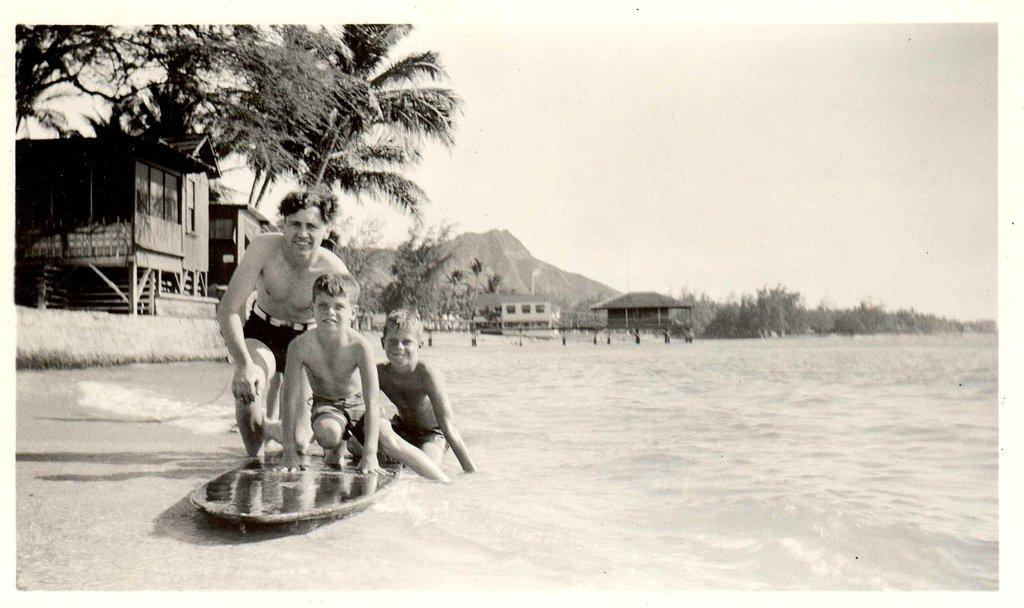What are the people in the image standing on? The people are on an object in the image. What can be seen below the object in the image? The ground is visible in the image. What type of structures can be seen in the image? There are water huts in the image. What type of natural features are present in the image? Trees and mountains are present in the image. What is visible above the object in the image? The sky is visible in the image. What is the price of the governor's mansion in the image? There is no governor's mansion present in the image, and therefore no price can be determined. 